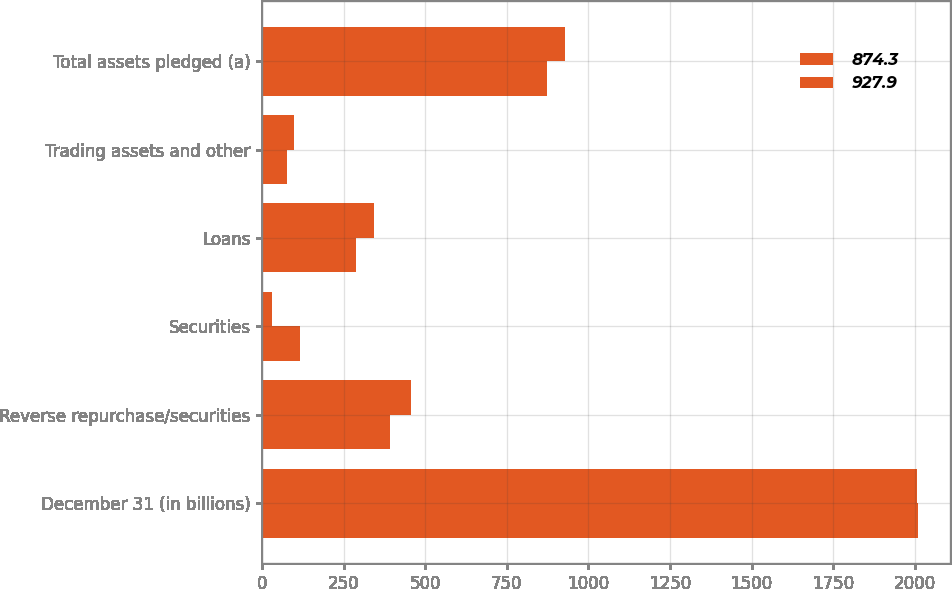<chart> <loc_0><loc_0><loc_500><loc_500><stacked_bar_chart><ecel><fcel>December 31 (in billions)<fcel>Reverse repurchase/securities<fcel>Securities<fcel>Loans<fcel>Trading assets and other<fcel>Total assets pledged (a)<nl><fcel>874.3<fcel>2009<fcel>392.9<fcel>115.6<fcel>289<fcel>76.8<fcel>874.3<nl><fcel>927.9<fcel>2008<fcel>456.6<fcel>31<fcel>342.3<fcel>98<fcel>927.9<nl></chart> 